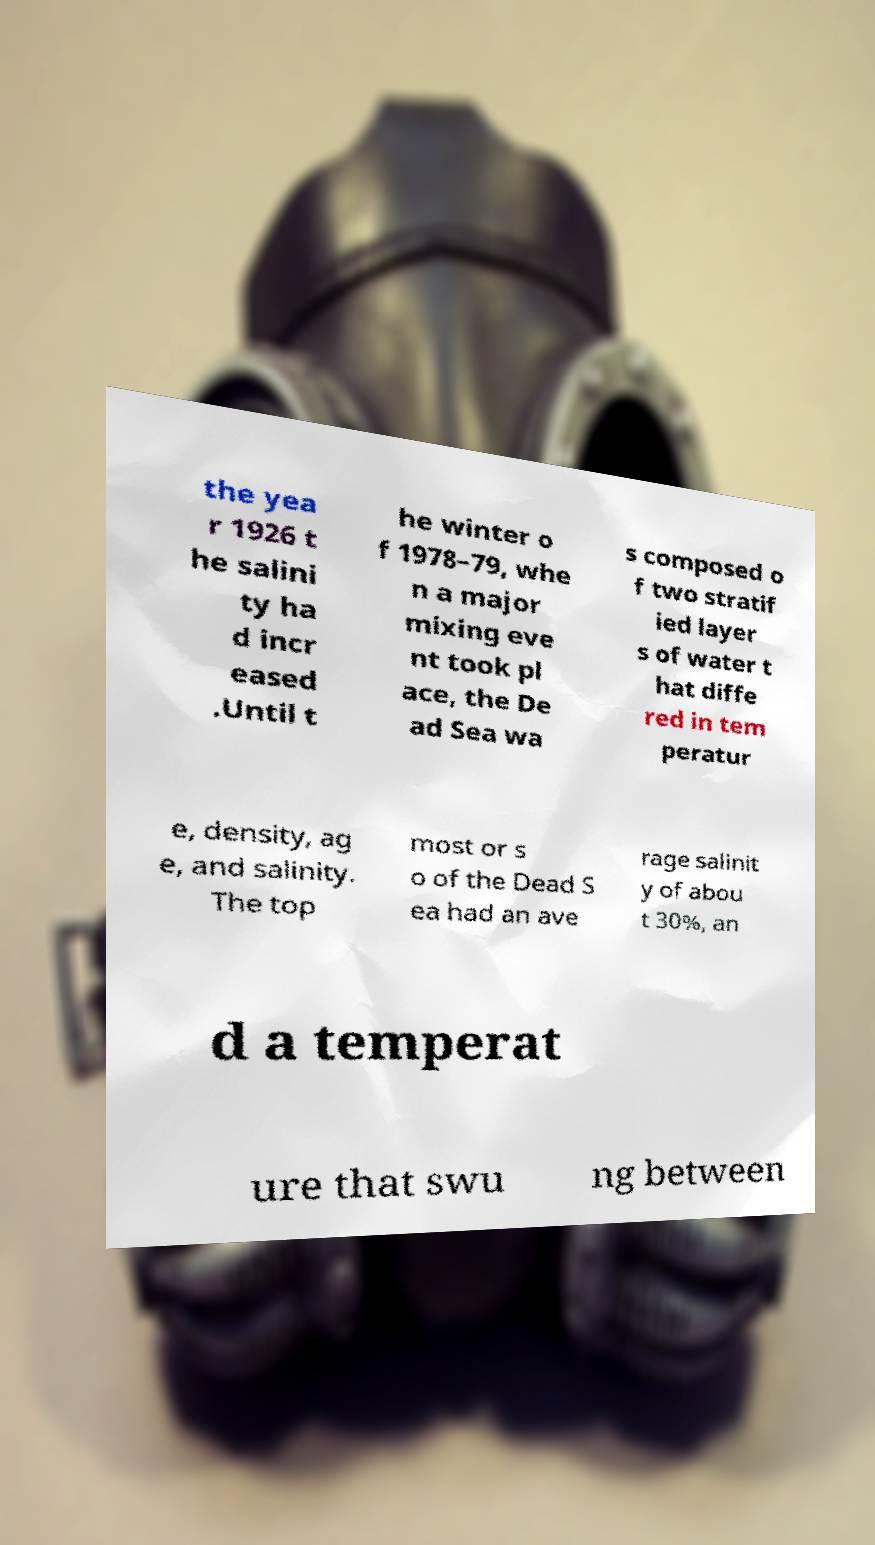Please read and relay the text visible in this image. What does it say? the yea r 1926 t he salini ty ha d incr eased .Until t he winter o f 1978–79, whe n a major mixing eve nt took pl ace, the De ad Sea wa s composed o f two stratif ied layer s of water t hat diffe red in tem peratur e, density, ag e, and salinity. The top most or s o of the Dead S ea had an ave rage salinit y of abou t 30%, an d a temperat ure that swu ng between 